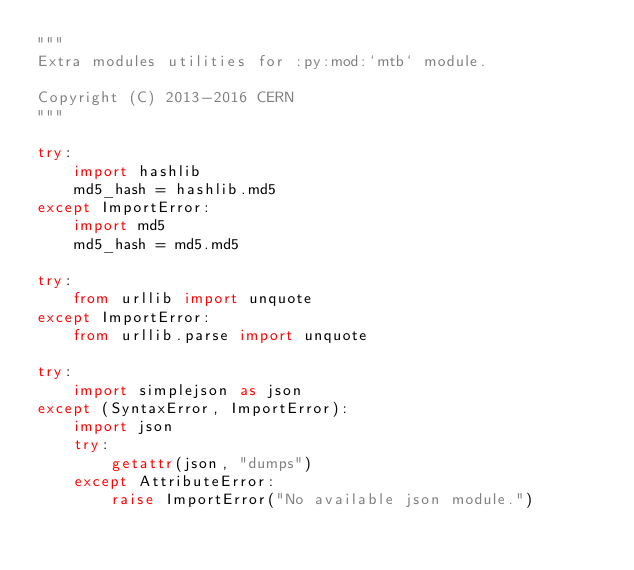Convert code to text. <code><loc_0><loc_0><loc_500><loc_500><_Python_>"""
Extra modules utilities for :py:mod:`mtb` module.

Copyright (C) 2013-2016 CERN
"""

try:
    import hashlib
    md5_hash = hashlib.md5
except ImportError:
    import md5
    md5_hash = md5.md5

try:
    from urllib import unquote
except ImportError:
    from urllib.parse import unquote

try:
    import simplejson as json
except (SyntaxError, ImportError):
    import json
    try:
        getattr(json, "dumps")
    except AttributeError:
        raise ImportError("No available json module.")
</code> 